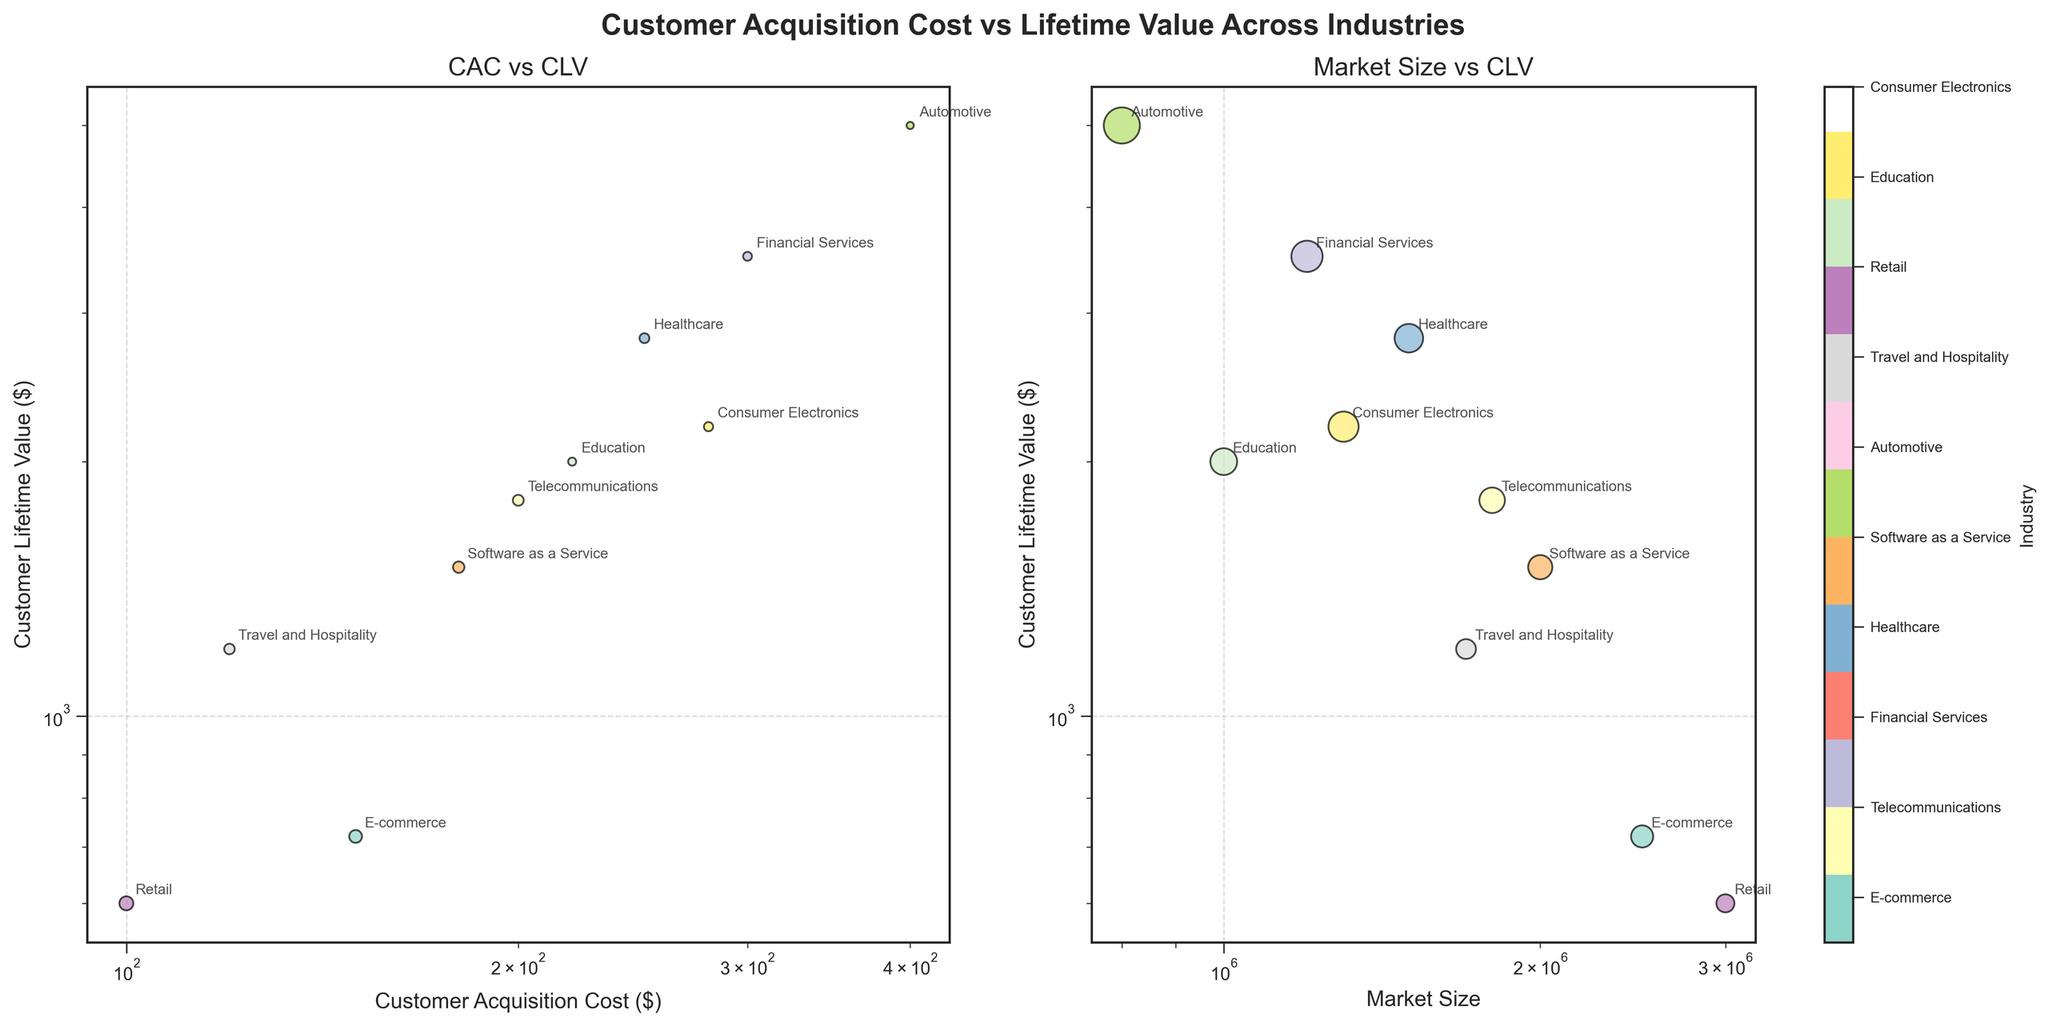what is the title of the Plot? The title of the plot is located at the top center of the figure in bold text. It provides an overall context for the viewer.
Answer: Customer Acquisition Cost vs Lifetime Value Across Industries how many industries are compared in the plots? You can count the number of unique bubble annotations or check the index of the colorbar legend on the right. Each unique label represents a different industry.
Answer: 10 what is the industry with the lowest customer acquisition cost? Look at the x-axis of the left subplot and locate the point with the smallest value. Then, check the corresponding annotation for the industry's name.
Answer: Retail which industry has the highest customer lifetime value? Look at the y-axis of the left subplot and identify the point with the highest value. Then, read the label to find the associated industry.
Answer: Automotive how does customer acquisition cost relate to customer lifetime value in Telecommunications? Locate the "Telecommunications" data point on the left subplot and describe how its Customer Acquisition Cost (CAC) and Customer Lifetime Value (CLV) compare with the other industries.
Answer: Medium CAC and High CLV compare the market size of the healthcare and financial services industries. which is larger? Find the data points for Healthcare and Financial Services on the right subplot and compare their positions on the x-axis.
Answer: Healthcare what is the rough range of customer acquisition cost values across the industries? Observe the extent of the x-axis in the left subplot where the data points are distributed. This will provide the range of reported Customer Acquisition Costs.
Answer: 100 to 400 which industry has the smallest market size and also has a clv above 2000? On the right subplot, look for the bubble with the smallest size but still has a y-value (CLV) above 2000, and check its label.
Answer: Education is there any industry where the market size is proportional to the customer lifetime value? On the right subplot, see if any industries have a relatively linear trend between Market Size on the x-axis and CLV on the y-axis. Consumer Electronics seem to display this relationship.
Answer: Consumer Electronics how do the CLVs of e-commerce and education compare? On either subplot, locate the data points for E-commerce and Education, and compare their positions on the y-axis to determine their CLVs.
Answer: Education is higher 